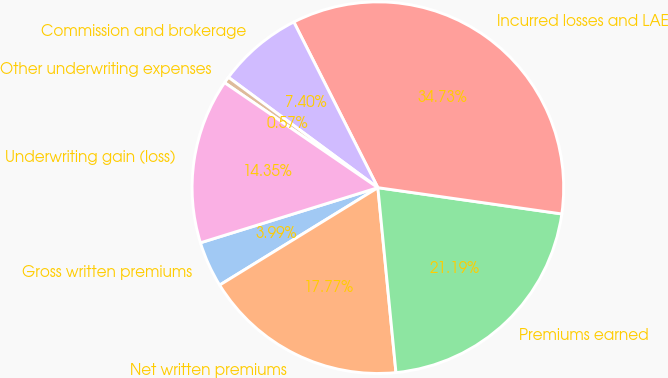Convert chart. <chart><loc_0><loc_0><loc_500><loc_500><pie_chart><fcel>Gross written premiums<fcel>Net written premiums<fcel>Premiums earned<fcel>Incurred losses and LAE<fcel>Commission and brokerage<fcel>Other underwriting expenses<fcel>Underwriting gain (loss)<nl><fcel>3.99%<fcel>17.77%<fcel>21.19%<fcel>34.73%<fcel>7.4%<fcel>0.57%<fcel>14.35%<nl></chart> 